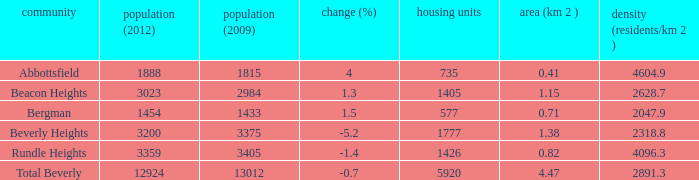How many Dwellings does Beverly Heights have that have a change percent larger than -5.2? None. 